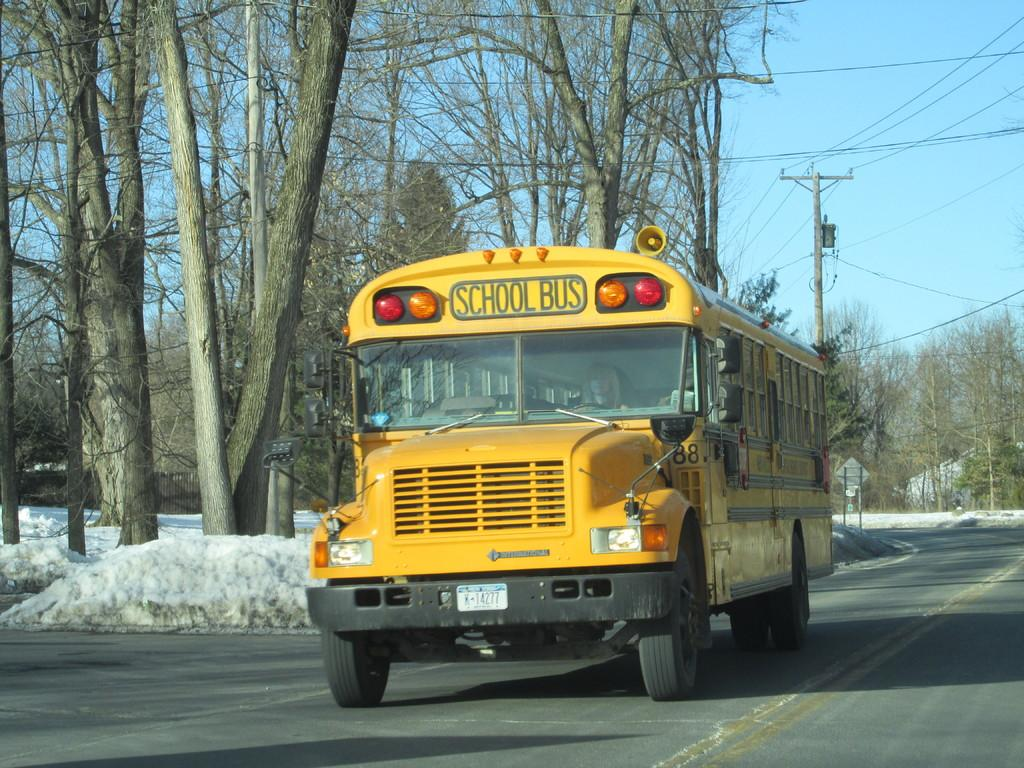<image>
Provide a brief description of the given image. School bus 88 is on a road that has snow piled up on the side. 